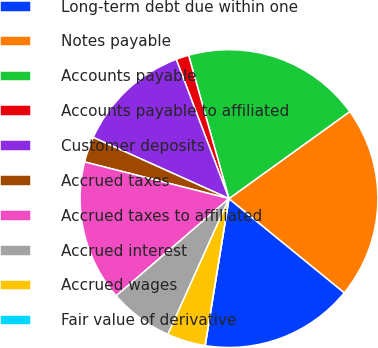<chart> <loc_0><loc_0><loc_500><loc_500><pie_chart><fcel>Long-term debt due within one<fcel>Notes payable<fcel>Accounts payable<fcel>Accounts payable to affiliated<fcel>Customer deposits<fcel>Accrued taxes<fcel>Accrued taxes to affiliated<fcel>Accrued interest<fcel>Accrued wages<fcel>Fair value of derivative<nl><fcel>16.66%<fcel>20.83%<fcel>19.44%<fcel>1.39%<fcel>12.5%<fcel>2.78%<fcel>15.28%<fcel>6.95%<fcel>4.17%<fcel>0.0%<nl></chart> 